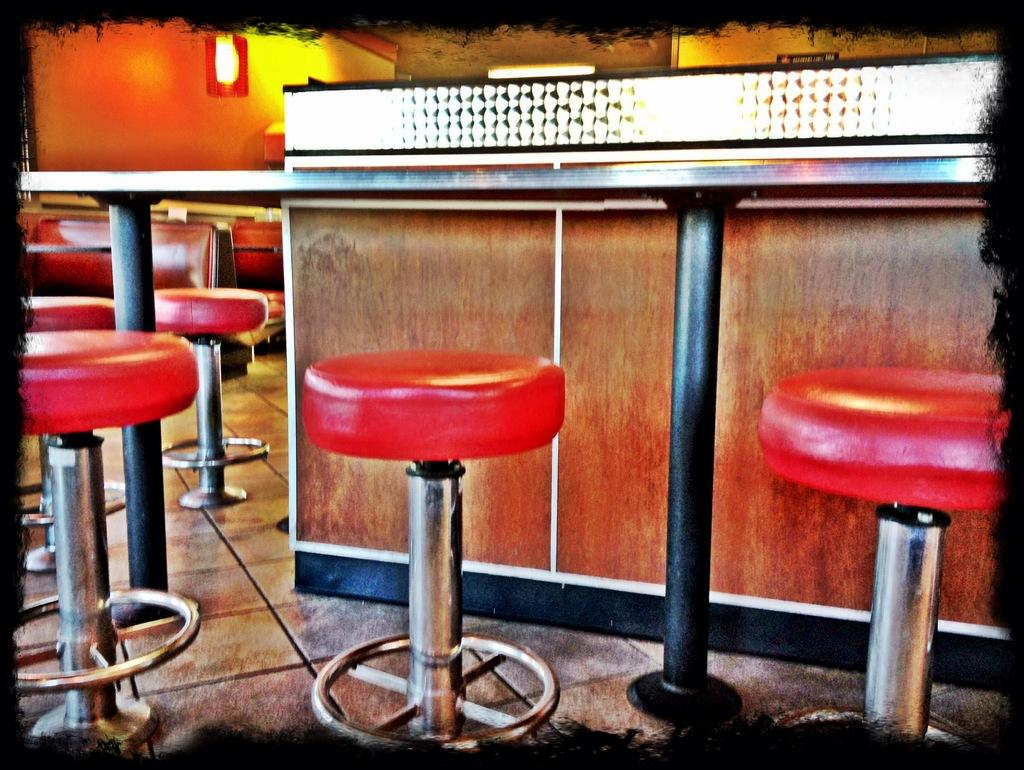What is located in the center of the image? There is a counter in the center of the image. What type of furniture is present in the image? Tables and stools are visible in the image. What can be seen at the bottom of the image? The floor is visible at the bottom of the image. Where is the wall located in the image? There is a wall at the top left corner of the image. What is present in the top left corner of the image? A light is present in the top left corner of the image. What type of cushion is on the sister's chair in the image? There is no sister or chair present in the image, so it is not possible to answer that question. 